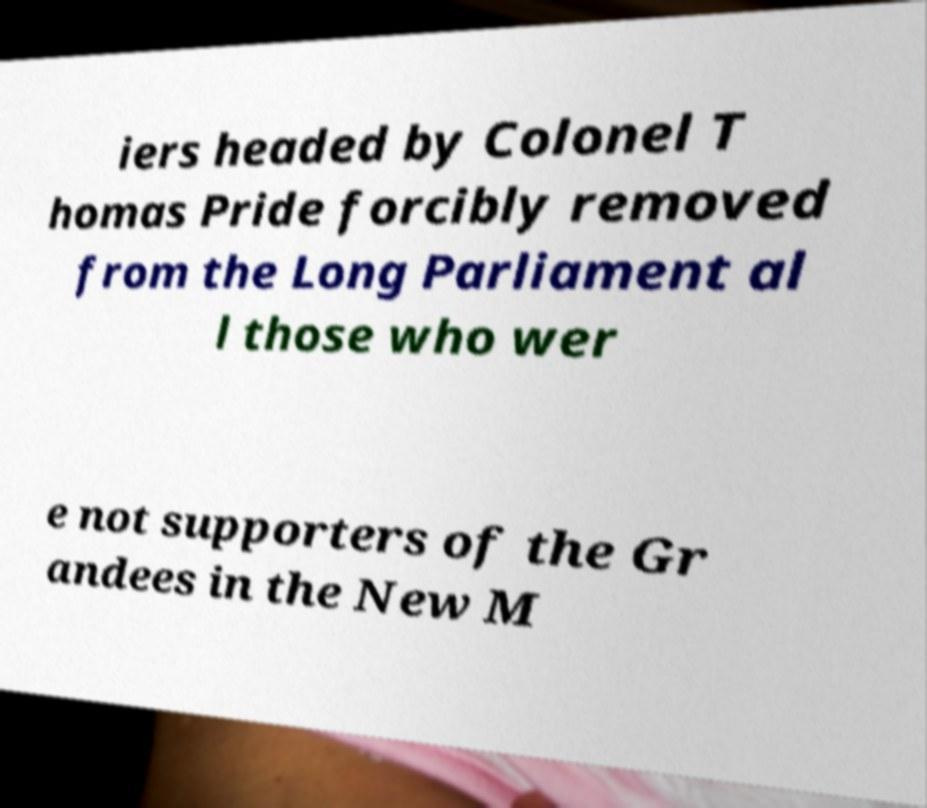Can you accurately transcribe the text from the provided image for me? iers headed by Colonel T homas Pride forcibly removed from the Long Parliament al l those who wer e not supporters of the Gr andees in the New M 